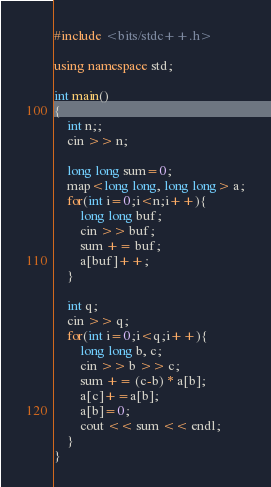<code> <loc_0><loc_0><loc_500><loc_500><_C++_>#include <bits/stdc++.h>

using namespace std;

int main()
{
    int n;;
    cin >> n;
    
    long long sum=0;
    map<long long, long long> a;
    for(int i=0;i<n;i++){
        long long buf;
        cin >> buf;
        sum += buf;
        a[buf]++;
    }

    int q;
    cin >> q;
    for(int i=0;i<q;i++){
        long long b, c;
        cin >> b >> c;
        sum += (c-b) * a[b];
        a[c]+=a[b];
        a[b]=0;
        cout << sum << endl;
    }
}</code> 